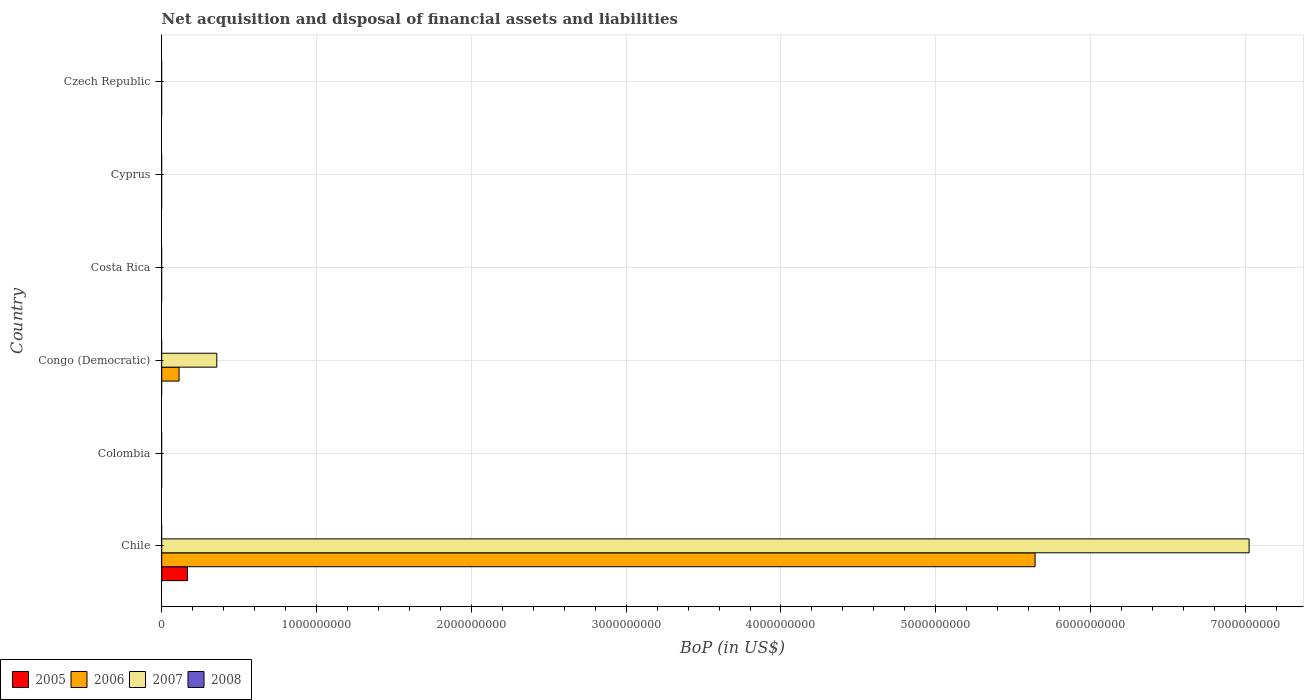How many different coloured bars are there?
Keep it short and to the point. 3. Are the number of bars on each tick of the Y-axis equal?
Your answer should be very brief. No. How many bars are there on the 2nd tick from the bottom?
Your response must be concise. 0. What is the label of the 2nd group of bars from the top?
Offer a terse response. Cyprus. Across all countries, what is the maximum Balance of Payments in 2005?
Make the answer very short. 1.66e+08. What is the total Balance of Payments in 2007 in the graph?
Ensure brevity in your answer.  7.38e+09. What is the difference between the Balance of Payments in 2007 in Congo (Democratic) and the Balance of Payments in 2006 in Colombia?
Provide a short and direct response. 3.56e+08. What is the average Balance of Payments in 2005 per country?
Offer a very short reply. 2.77e+07. What is the difference between the Balance of Payments in 2006 and Balance of Payments in 2005 in Chile?
Offer a terse response. 5.48e+09. What is the difference between the highest and the lowest Balance of Payments in 2005?
Give a very brief answer. 1.66e+08. How many bars are there?
Ensure brevity in your answer.  5. Are all the bars in the graph horizontal?
Provide a short and direct response. Yes. How many countries are there in the graph?
Ensure brevity in your answer.  6. What is the difference between two consecutive major ticks on the X-axis?
Your answer should be compact. 1.00e+09. How are the legend labels stacked?
Ensure brevity in your answer.  Horizontal. What is the title of the graph?
Your answer should be very brief. Net acquisition and disposal of financial assets and liabilities. Does "1971" appear as one of the legend labels in the graph?
Ensure brevity in your answer.  No. What is the label or title of the X-axis?
Give a very brief answer. BoP (in US$). What is the label or title of the Y-axis?
Offer a very short reply. Country. What is the BoP (in US$) in 2005 in Chile?
Ensure brevity in your answer.  1.66e+08. What is the BoP (in US$) of 2006 in Chile?
Provide a short and direct response. 5.64e+09. What is the BoP (in US$) of 2007 in Chile?
Provide a succinct answer. 7.02e+09. What is the BoP (in US$) of 2008 in Chile?
Give a very brief answer. 0. What is the BoP (in US$) of 2005 in Colombia?
Offer a very short reply. 0. What is the BoP (in US$) of 2005 in Congo (Democratic)?
Provide a succinct answer. 0. What is the BoP (in US$) in 2006 in Congo (Democratic)?
Provide a short and direct response. 1.12e+08. What is the BoP (in US$) in 2007 in Congo (Democratic)?
Keep it short and to the point. 3.56e+08. What is the BoP (in US$) in 2008 in Congo (Democratic)?
Your response must be concise. 0. What is the BoP (in US$) of 2005 in Costa Rica?
Make the answer very short. 0. What is the BoP (in US$) in 2006 in Costa Rica?
Give a very brief answer. 0. What is the BoP (in US$) of 2007 in Costa Rica?
Give a very brief answer. 0. What is the BoP (in US$) in 2006 in Cyprus?
Your answer should be compact. 0. What is the BoP (in US$) of 2007 in Cyprus?
Provide a short and direct response. 0. What is the BoP (in US$) of 2008 in Cyprus?
Your answer should be very brief. 0. What is the BoP (in US$) in 2005 in Czech Republic?
Your answer should be compact. 0. What is the BoP (in US$) in 2006 in Czech Republic?
Your answer should be very brief. 0. What is the BoP (in US$) of 2007 in Czech Republic?
Provide a succinct answer. 0. Across all countries, what is the maximum BoP (in US$) of 2005?
Give a very brief answer. 1.66e+08. Across all countries, what is the maximum BoP (in US$) of 2006?
Provide a succinct answer. 5.64e+09. Across all countries, what is the maximum BoP (in US$) of 2007?
Provide a short and direct response. 7.02e+09. Across all countries, what is the minimum BoP (in US$) of 2005?
Ensure brevity in your answer.  0. Across all countries, what is the minimum BoP (in US$) in 2007?
Keep it short and to the point. 0. What is the total BoP (in US$) of 2005 in the graph?
Keep it short and to the point. 1.66e+08. What is the total BoP (in US$) in 2006 in the graph?
Offer a very short reply. 5.75e+09. What is the total BoP (in US$) in 2007 in the graph?
Your response must be concise. 7.38e+09. What is the difference between the BoP (in US$) of 2006 in Chile and that in Congo (Democratic)?
Your answer should be very brief. 5.53e+09. What is the difference between the BoP (in US$) of 2007 in Chile and that in Congo (Democratic)?
Keep it short and to the point. 6.67e+09. What is the difference between the BoP (in US$) in 2005 in Chile and the BoP (in US$) in 2006 in Congo (Democratic)?
Offer a very short reply. 5.40e+07. What is the difference between the BoP (in US$) in 2005 in Chile and the BoP (in US$) in 2007 in Congo (Democratic)?
Provide a succinct answer. -1.90e+08. What is the difference between the BoP (in US$) of 2006 in Chile and the BoP (in US$) of 2007 in Congo (Democratic)?
Your response must be concise. 5.29e+09. What is the average BoP (in US$) of 2005 per country?
Make the answer very short. 2.77e+07. What is the average BoP (in US$) of 2006 per country?
Provide a succinct answer. 9.59e+08. What is the average BoP (in US$) in 2007 per country?
Your answer should be very brief. 1.23e+09. What is the average BoP (in US$) in 2008 per country?
Your answer should be very brief. 0. What is the difference between the BoP (in US$) of 2005 and BoP (in US$) of 2006 in Chile?
Provide a succinct answer. -5.48e+09. What is the difference between the BoP (in US$) of 2005 and BoP (in US$) of 2007 in Chile?
Make the answer very short. -6.86e+09. What is the difference between the BoP (in US$) in 2006 and BoP (in US$) in 2007 in Chile?
Provide a short and direct response. -1.38e+09. What is the difference between the BoP (in US$) of 2006 and BoP (in US$) of 2007 in Congo (Democratic)?
Your answer should be compact. -2.44e+08. What is the ratio of the BoP (in US$) of 2006 in Chile to that in Congo (Democratic)?
Your response must be concise. 50.33. What is the ratio of the BoP (in US$) in 2007 in Chile to that in Congo (Democratic)?
Make the answer very short. 19.74. What is the difference between the highest and the lowest BoP (in US$) in 2005?
Provide a short and direct response. 1.66e+08. What is the difference between the highest and the lowest BoP (in US$) of 2006?
Provide a short and direct response. 5.64e+09. What is the difference between the highest and the lowest BoP (in US$) in 2007?
Provide a succinct answer. 7.02e+09. 